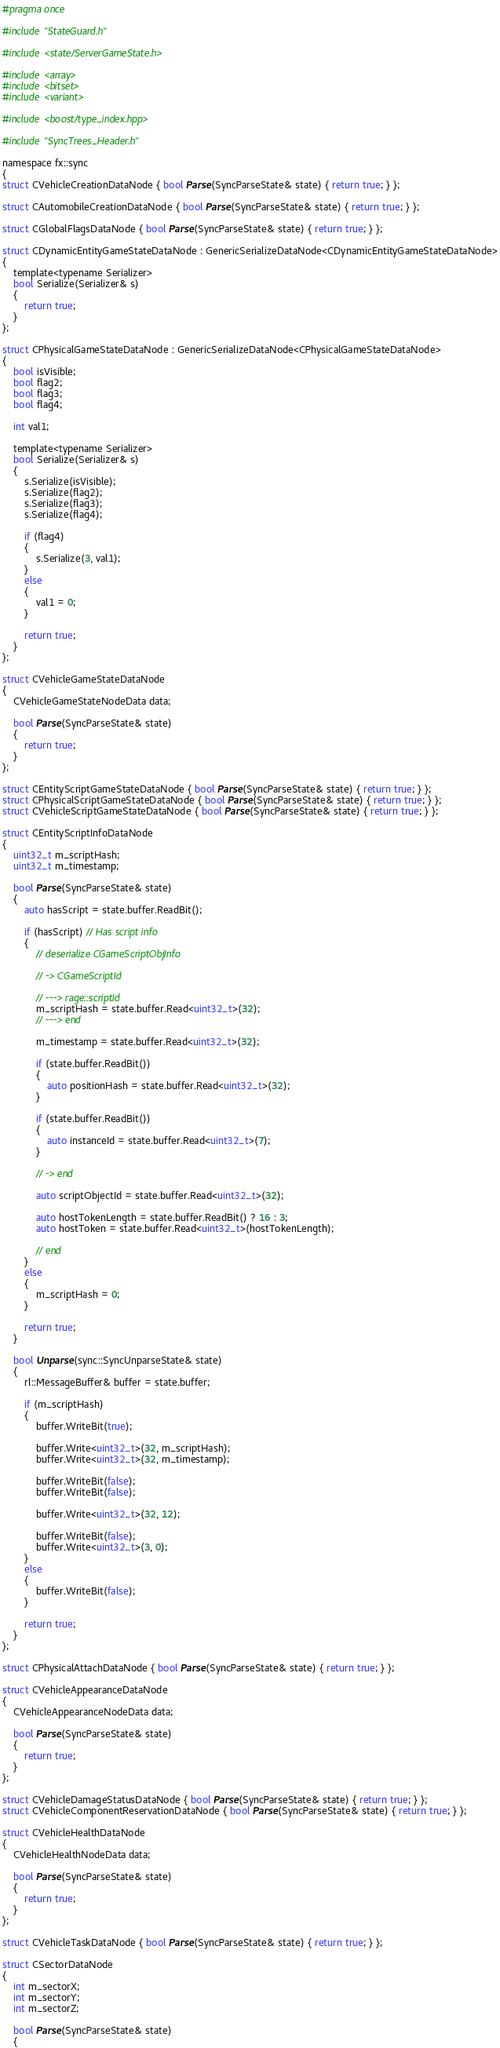<code> <loc_0><loc_0><loc_500><loc_500><_C_>#pragma once

#include "StateGuard.h"

#include <state/ServerGameState.h>

#include <array>
#include <bitset>
#include <variant>

#include <boost/type_index.hpp>

#include "SyncTrees_Header.h"

namespace fx::sync
{
struct CVehicleCreationDataNode { bool Parse(SyncParseState& state) { return true; } };

struct CAutomobileCreationDataNode { bool Parse(SyncParseState& state) { return true; } };

struct CGlobalFlagsDataNode { bool Parse(SyncParseState& state) { return true; } };

struct CDynamicEntityGameStateDataNode : GenericSerializeDataNode<CDynamicEntityGameStateDataNode>
{
	template<typename Serializer>
	bool Serialize(Serializer& s)
	{
		return true;
	}
};

struct CPhysicalGameStateDataNode : GenericSerializeDataNode<CPhysicalGameStateDataNode>
{
	bool isVisible;
	bool flag2;
	bool flag3;
	bool flag4;

	int val1;

	template<typename Serializer>
	bool Serialize(Serializer& s)
	{
		s.Serialize(isVisible);
		s.Serialize(flag2);
		s.Serialize(flag3);
		s.Serialize(flag4);

		if (flag4)
		{
			s.Serialize(3, val1);
		}
		else
		{
			val1 = 0;
		}

		return true;
	}
};

struct CVehicleGameStateDataNode
{
	CVehicleGameStateNodeData data;

	bool Parse(SyncParseState& state)
	{
		return true;
	}
};

struct CEntityScriptGameStateDataNode { bool Parse(SyncParseState& state) { return true; } };
struct CPhysicalScriptGameStateDataNode { bool Parse(SyncParseState& state) { return true; } };
struct CVehicleScriptGameStateDataNode { bool Parse(SyncParseState& state) { return true; } };

struct CEntityScriptInfoDataNode
{
	uint32_t m_scriptHash;
	uint32_t m_timestamp;

	bool Parse(SyncParseState& state)
	{
		auto hasScript = state.buffer.ReadBit();

		if (hasScript) // Has script info
		{
			// deserialize CGameScriptObjInfo

			// -> CGameScriptId

			// ---> rage::scriptId
			m_scriptHash = state.buffer.Read<uint32_t>(32);
			// ---> end

			m_timestamp = state.buffer.Read<uint32_t>(32);

			if (state.buffer.ReadBit())
			{
				auto positionHash = state.buffer.Read<uint32_t>(32);
			}

			if (state.buffer.ReadBit())
			{
				auto instanceId = state.buffer.Read<uint32_t>(7);
			}

			// -> end

			auto scriptObjectId = state.buffer.Read<uint32_t>(32);

			auto hostTokenLength = state.buffer.ReadBit() ? 16 : 3;
			auto hostToken = state.buffer.Read<uint32_t>(hostTokenLength);

			// end
		}
		else
		{
			m_scriptHash = 0;
		}

		return true;
	}

	bool Unparse(sync::SyncUnparseState& state)
	{
		rl::MessageBuffer& buffer = state.buffer;

		if (m_scriptHash)
		{
			buffer.WriteBit(true);

			buffer.Write<uint32_t>(32, m_scriptHash);
			buffer.Write<uint32_t>(32, m_timestamp);

			buffer.WriteBit(false);
			buffer.WriteBit(false);

			buffer.Write<uint32_t>(32, 12);

			buffer.WriteBit(false);
			buffer.Write<uint32_t>(3, 0);
		}
		else
		{
			buffer.WriteBit(false);
		}

		return true;
	}
};

struct CPhysicalAttachDataNode { bool Parse(SyncParseState& state) { return true; } };

struct CVehicleAppearanceDataNode
{
	CVehicleAppearanceNodeData data;

	bool Parse(SyncParseState& state)
	{
		return true;
	}
};

struct CVehicleDamageStatusDataNode { bool Parse(SyncParseState& state) { return true; } };
struct CVehicleComponentReservationDataNode { bool Parse(SyncParseState& state) { return true; } };

struct CVehicleHealthDataNode
{
	CVehicleHealthNodeData data;

	bool Parse(SyncParseState& state)
	{
		return true;
	}
};

struct CVehicleTaskDataNode { bool Parse(SyncParseState& state) { return true; } };

struct CSectorDataNode
{
	int m_sectorX;
	int m_sectorY;
	int m_sectorZ;

	bool Parse(SyncParseState& state)
	{</code> 